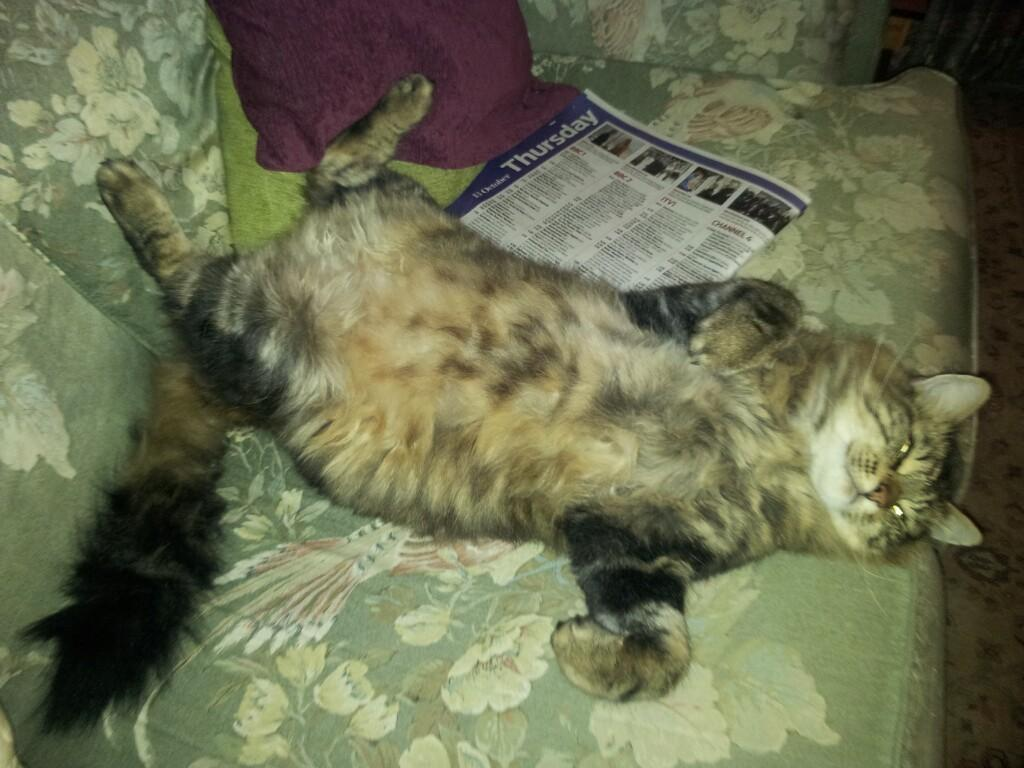What color is the sofa in the image? The sofa in the image is green. What is on the sofa in the image? There is a cat on the sofa and a white color paper. What else can be seen on the sofa? There are cushions on the sofa. How does the cat's behavior change when it sees a worm in the image? There is no worm present in the image, so it is not possible to determine how the cat's behavior would change in response to a worm. 